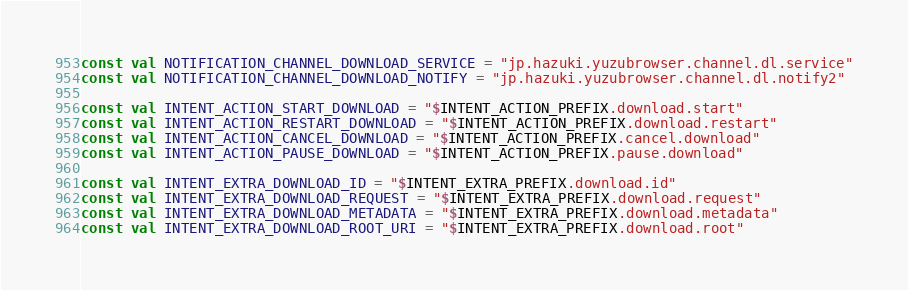<code> <loc_0><loc_0><loc_500><loc_500><_Kotlin_>const val NOTIFICATION_CHANNEL_DOWNLOAD_SERVICE = "jp.hazuki.yuzubrowser.channel.dl.service"
const val NOTIFICATION_CHANNEL_DOWNLOAD_NOTIFY = "jp.hazuki.yuzubrowser.channel.dl.notify2"

const val INTENT_ACTION_START_DOWNLOAD = "$INTENT_ACTION_PREFIX.download.start"
const val INTENT_ACTION_RESTART_DOWNLOAD = "$INTENT_ACTION_PREFIX.download.restart"
const val INTENT_ACTION_CANCEL_DOWNLOAD = "$INTENT_ACTION_PREFIX.cancel.download"
const val INTENT_ACTION_PAUSE_DOWNLOAD = "$INTENT_ACTION_PREFIX.pause.download"

const val INTENT_EXTRA_DOWNLOAD_ID = "$INTENT_EXTRA_PREFIX.download.id"
const val INTENT_EXTRA_DOWNLOAD_REQUEST = "$INTENT_EXTRA_PREFIX.download.request"
const val INTENT_EXTRA_DOWNLOAD_METADATA = "$INTENT_EXTRA_PREFIX.download.metadata"
const val INTENT_EXTRA_DOWNLOAD_ROOT_URI = "$INTENT_EXTRA_PREFIX.download.root"</code> 